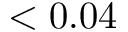Convert formula to latex. <formula><loc_0><loc_0><loc_500><loc_500>< 0 . 0 4</formula> 